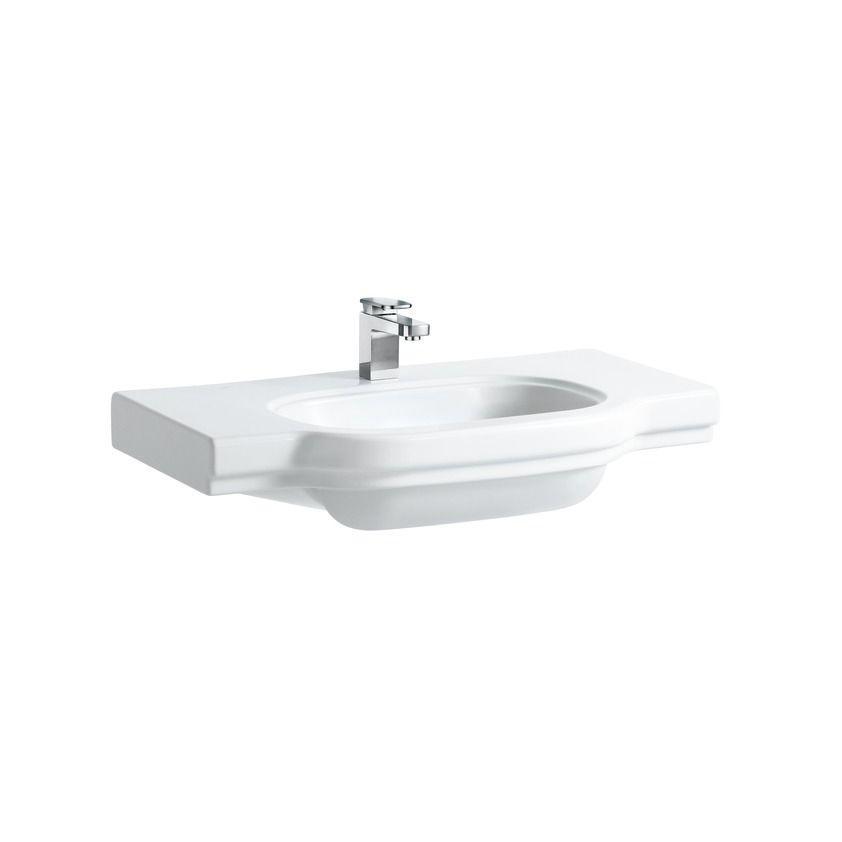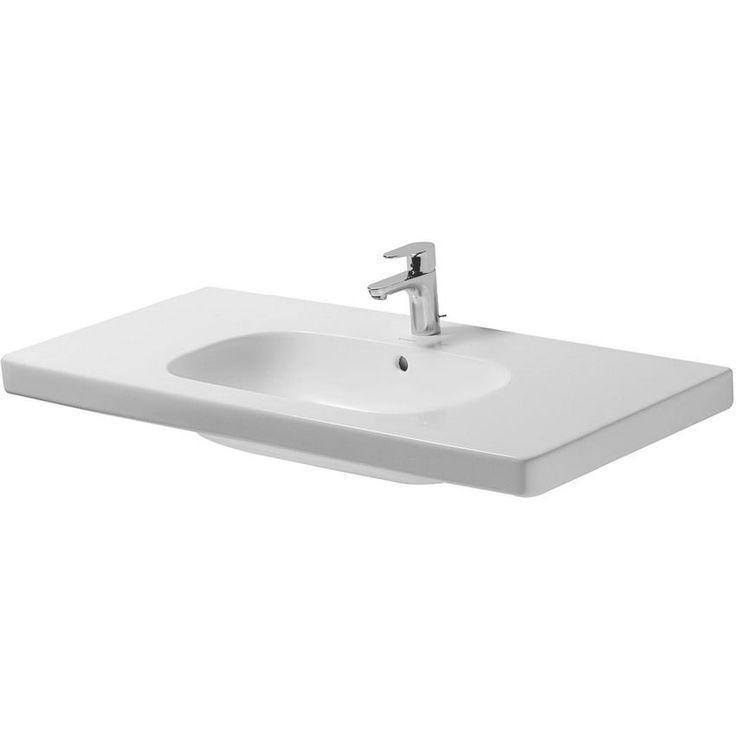The first image is the image on the left, the second image is the image on the right. For the images shown, is this caption "Each sink is a single-basin design inset in a white rectangle that is straight across the front." true? Answer yes or no. No. The first image is the image on the left, the second image is the image on the right. Considering the images on both sides, is "One of the faucets attached to a sink is facing slightly to the right." valid? Answer yes or no. Yes. 